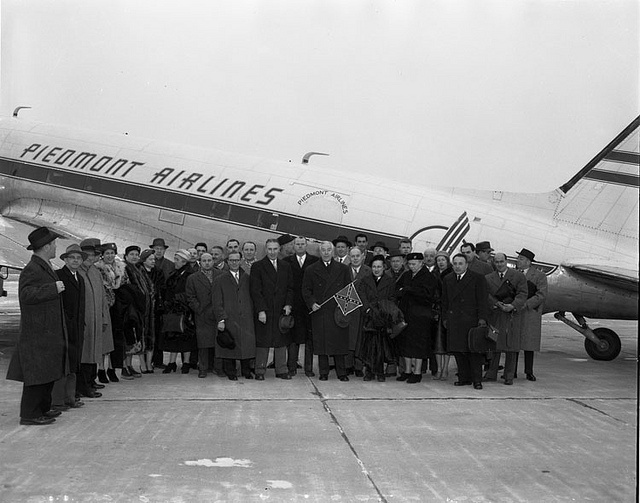Describe the objects in this image and their specific colors. I can see airplane in white, lightgray, darkgray, black, and gray tones, people in white, black, gray, darkgray, and lightgray tones, people in white, black, gray, darkgray, and lightgray tones, people in white, black, gray, and lightgray tones, and people in white, black, gray, and lightgray tones in this image. 